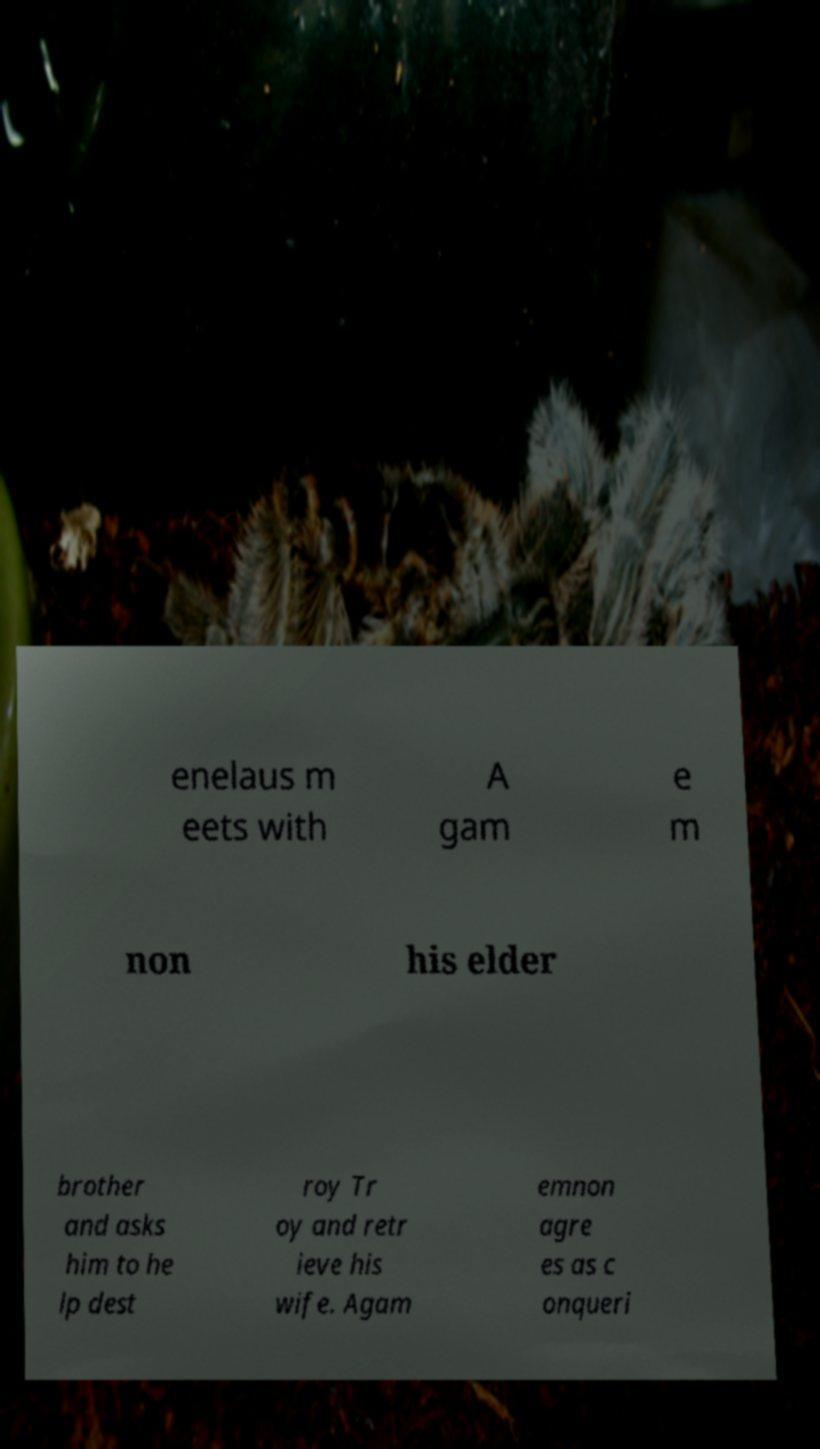Could you assist in decoding the text presented in this image and type it out clearly? enelaus m eets with A gam e m non his elder brother and asks him to he lp dest roy Tr oy and retr ieve his wife. Agam emnon agre es as c onqueri 